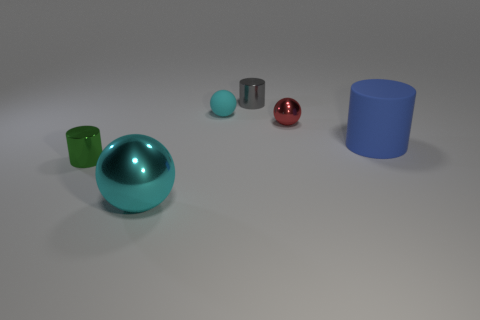Subtract all large blue cylinders. How many cylinders are left? 2 Subtract 1 cylinders. How many cylinders are left? 2 Subtract all blue cubes. How many cyan balls are left? 2 Add 1 large blue rubber cylinders. How many objects exist? 7 Subtract all brown cylinders. Subtract all purple balls. How many cylinders are left? 3 Subtract all large red matte cubes. Subtract all rubber spheres. How many objects are left? 5 Add 1 tiny metal things. How many tiny metal things are left? 4 Add 4 tiny green objects. How many tiny green objects exist? 5 Subtract 0 green spheres. How many objects are left? 6 